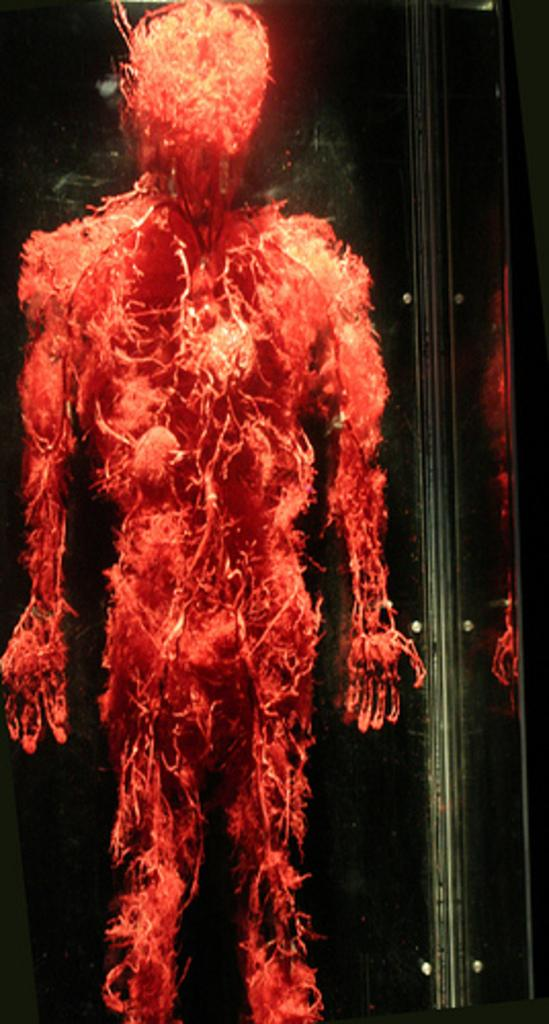What is the main subject of the image? The main subject of the image is the human circulatory system. What color is used to depict the human circulatory system in the image? The human circulatory system is depicted in red color in the image. How many tins of oranges are present in the image? There are no tins or oranges present in the image; it features a human circulatory system depicted in red color. What type of destruction can be seen in the image? There is no destruction present in the image; it features a human circulatory system depicted in red color. 